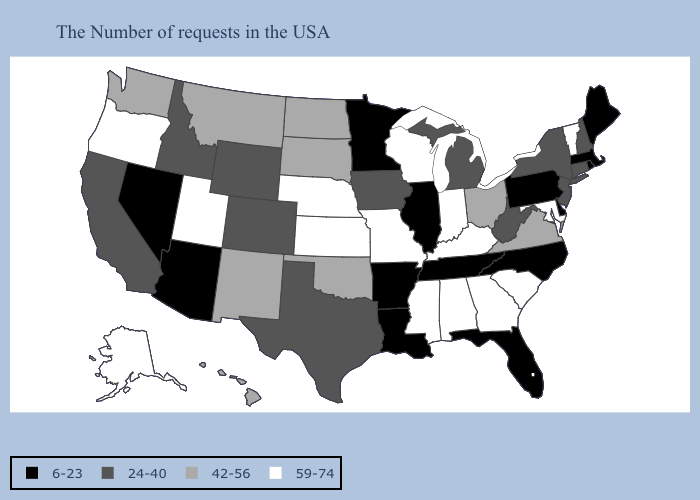Which states hav the highest value in the West?
Write a very short answer. Utah, Oregon, Alaska. Among the states that border Virginia , does West Virginia have the highest value?
Answer briefly. No. Among the states that border Virginia , does Tennessee have the lowest value?
Answer briefly. Yes. Which states have the lowest value in the MidWest?
Short answer required. Illinois, Minnesota. What is the lowest value in the USA?
Write a very short answer. 6-23. Which states have the highest value in the USA?
Keep it brief. Vermont, Maryland, South Carolina, Georgia, Kentucky, Indiana, Alabama, Wisconsin, Mississippi, Missouri, Kansas, Nebraska, Utah, Oregon, Alaska. What is the value of Wisconsin?
Quick response, please. 59-74. Name the states that have a value in the range 6-23?
Concise answer only. Maine, Massachusetts, Rhode Island, Delaware, Pennsylvania, North Carolina, Florida, Tennessee, Illinois, Louisiana, Arkansas, Minnesota, Arizona, Nevada. Among the states that border North Carolina , does Tennessee have the highest value?
Answer briefly. No. Name the states that have a value in the range 59-74?
Quick response, please. Vermont, Maryland, South Carolina, Georgia, Kentucky, Indiana, Alabama, Wisconsin, Mississippi, Missouri, Kansas, Nebraska, Utah, Oregon, Alaska. Does Massachusetts have the highest value in the Northeast?
Give a very brief answer. No. Does Iowa have a lower value than Utah?
Short answer required. Yes. Does Arizona have the same value as Illinois?
Answer briefly. Yes. Among the states that border North Dakota , does Minnesota have the lowest value?
Be succinct. Yes. What is the value of South Dakota?
Concise answer only. 42-56. 